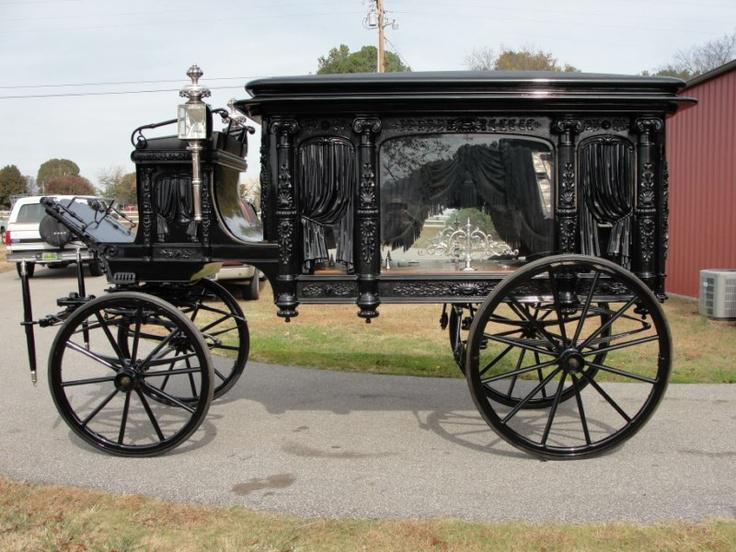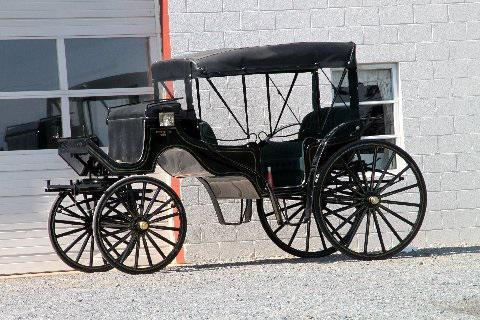The first image is the image on the left, the second image is the image on the right. For the images displayed, is the sentence "The carriages in both photos are facing to the left." factually correct? Answer yes or no. Yes. 